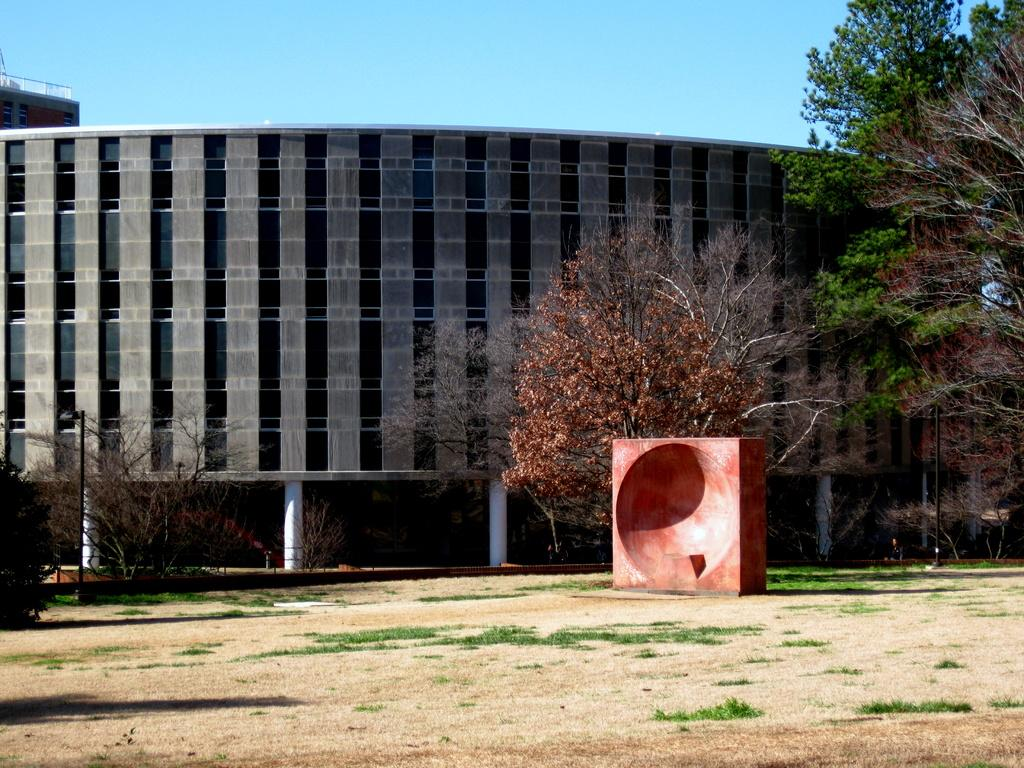What type of structure is present in the image? There is a wooden structure in the image. What else can be seen in the image besides the wooden structure? There are light poles and trees in the image. What is visible in the background of the image? There are buildings and the sky visible in the background of the image. How many letters are being touched by the tree in the image? There are no letters present in the image, and trees cannot touch or interact with letters. 